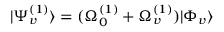Convert formula to latex. <formula><loc_0><loc_0><loc_500><loc_500>| \Psi _ { v } ^ { ( 1 ) } \rangle = ( \Omega _ { 0 } ^ { ( 1 ) } + \Omega _ { v } ^ { ( 1 ) } ) | \Phi _ { v } \rangle</formula> 